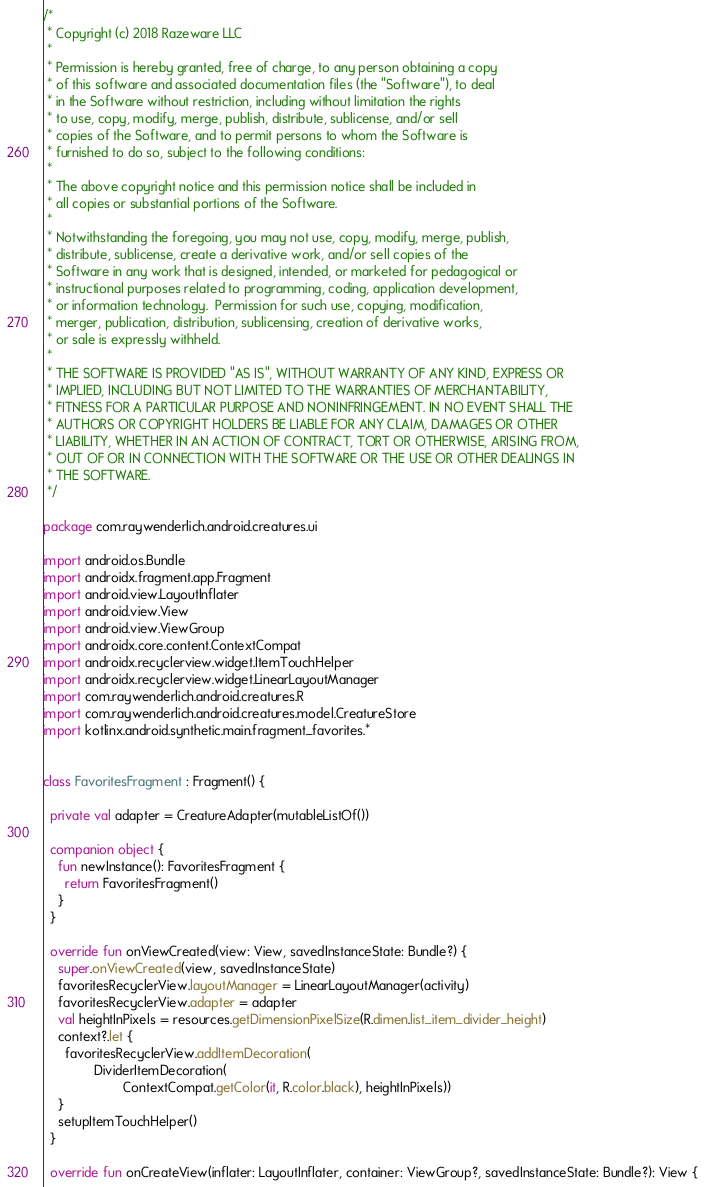<code> <loc_0><loc_0><loc_500><loc_500><_Kotlin_>/*
 * Copyright (c) 2018 Razeware LLC
 *
 * Permission is hereby granted, free of charge, to any person obtaining a copy
 * of this software and associated documentation files (the "Software"), to deal
 * in the Software without restriction, including without limitation the rights
 * to use, copy, modify, merge, publish, distribute, sublicense, and/or sell
 * copies of the Software, and to permit persons to whom the Software is
 * furnished to do so, subject to the following conditions:
 *
 * The above copyright notice and this permission notice shall be included in
 * all copies or substantial portions of the Software.
 *
 * Notwithstanding the foregoing, you may not use, copy, modify, merge, publish,
 * distribute, sublicense, create a derivative work, and/or sell copies of the
 * Software in any work that is designed, intended, or marketed for pedagogical or
 * instructional purposes related to programming, coding, application development,
 * or information technology.  Permission for such use, copying, modification,
 * merger, publication, distribution, sublicensing, creation of derivative works,
 * or sale is expressly withheld.
 *
 * THE SOFTWARE IS PROVIDED "AS IS", WITHOUT WARRANTY OF ANY KIND, EXPRESS OR
 * IMPLIED, INCLUDING BUT NOT LIMITED TO THE WARRANTIES OF MERCHANTABILITY,
 * FITNESS FOR A PARTICULAR PURPOSE AND NONINFRINGEMENT. IN NO EVENT SHALL THE
 * AUTHORS OR COPYRIGHT HOLDERS BE LIABLE FOR ANY CLAIM, DAMAGES OR OTHER
 * LIABILITY, WHETHER IN AN ACTION OF CONTRACT, TORT OR OTHERWISE, ARISING FROM,
 * OUT OF OR IN CONNECTION WITH THE SOFTWARE OR THE USE OR OTHER DEALINGS IN
 * THE SOFTWARE.
 */

package com.raywenderlich.android.creatures.ui

import android.os.Bundle
import androidx.fragment.app.Fragment
import android.view.LayoutInflater
import android.view.View
import android.view.ViewGroup
import androidx.core.content.ContextCompat
import androidx.recyclerview.widget.ItemTouchHelper
import androidx.recyclerview.widget.LinearLayoutManager
import com.raywenderlich.android.creatures.R
import com.raywenderlich.android.creatures.model.CreatureStore
import kotlinx.android.synthetic.main.fragment_favorites.*


class FavoritesFragment : Fragment() {

  private val adapter = CreatureAdapter(mutableListOf())

  companion object {
    fun newInstance(): FavoritesFragment {
      return FavoritesFragment()
    }
  }

  override fun onViewCreated(view: View, savedInstanceState: Bundle?) {
    super.onViewCreated(view, savedInstanceState)
    favoritesRecyclerView.layoutManager = LinearLayoutManager(activity)
    favoritesRecyclerView.adapter = adapter
    val heightInPixels = resources.getDimensionPixelSize(R.dimen.list_item_divider_height)
    context?.let {
      favoritesRecyclerView.addItemDecoration(
              DividerItemDecoration(
                      ContextCompat.getColor(it, R.color.black), heightInPixels))
    }
    setupItemTouchHelper()
  }

  override fun onCreateView(inflater: LayoutInflater, container: ViewGroup?, savedInstanceState: Bundle?): View {</code> 